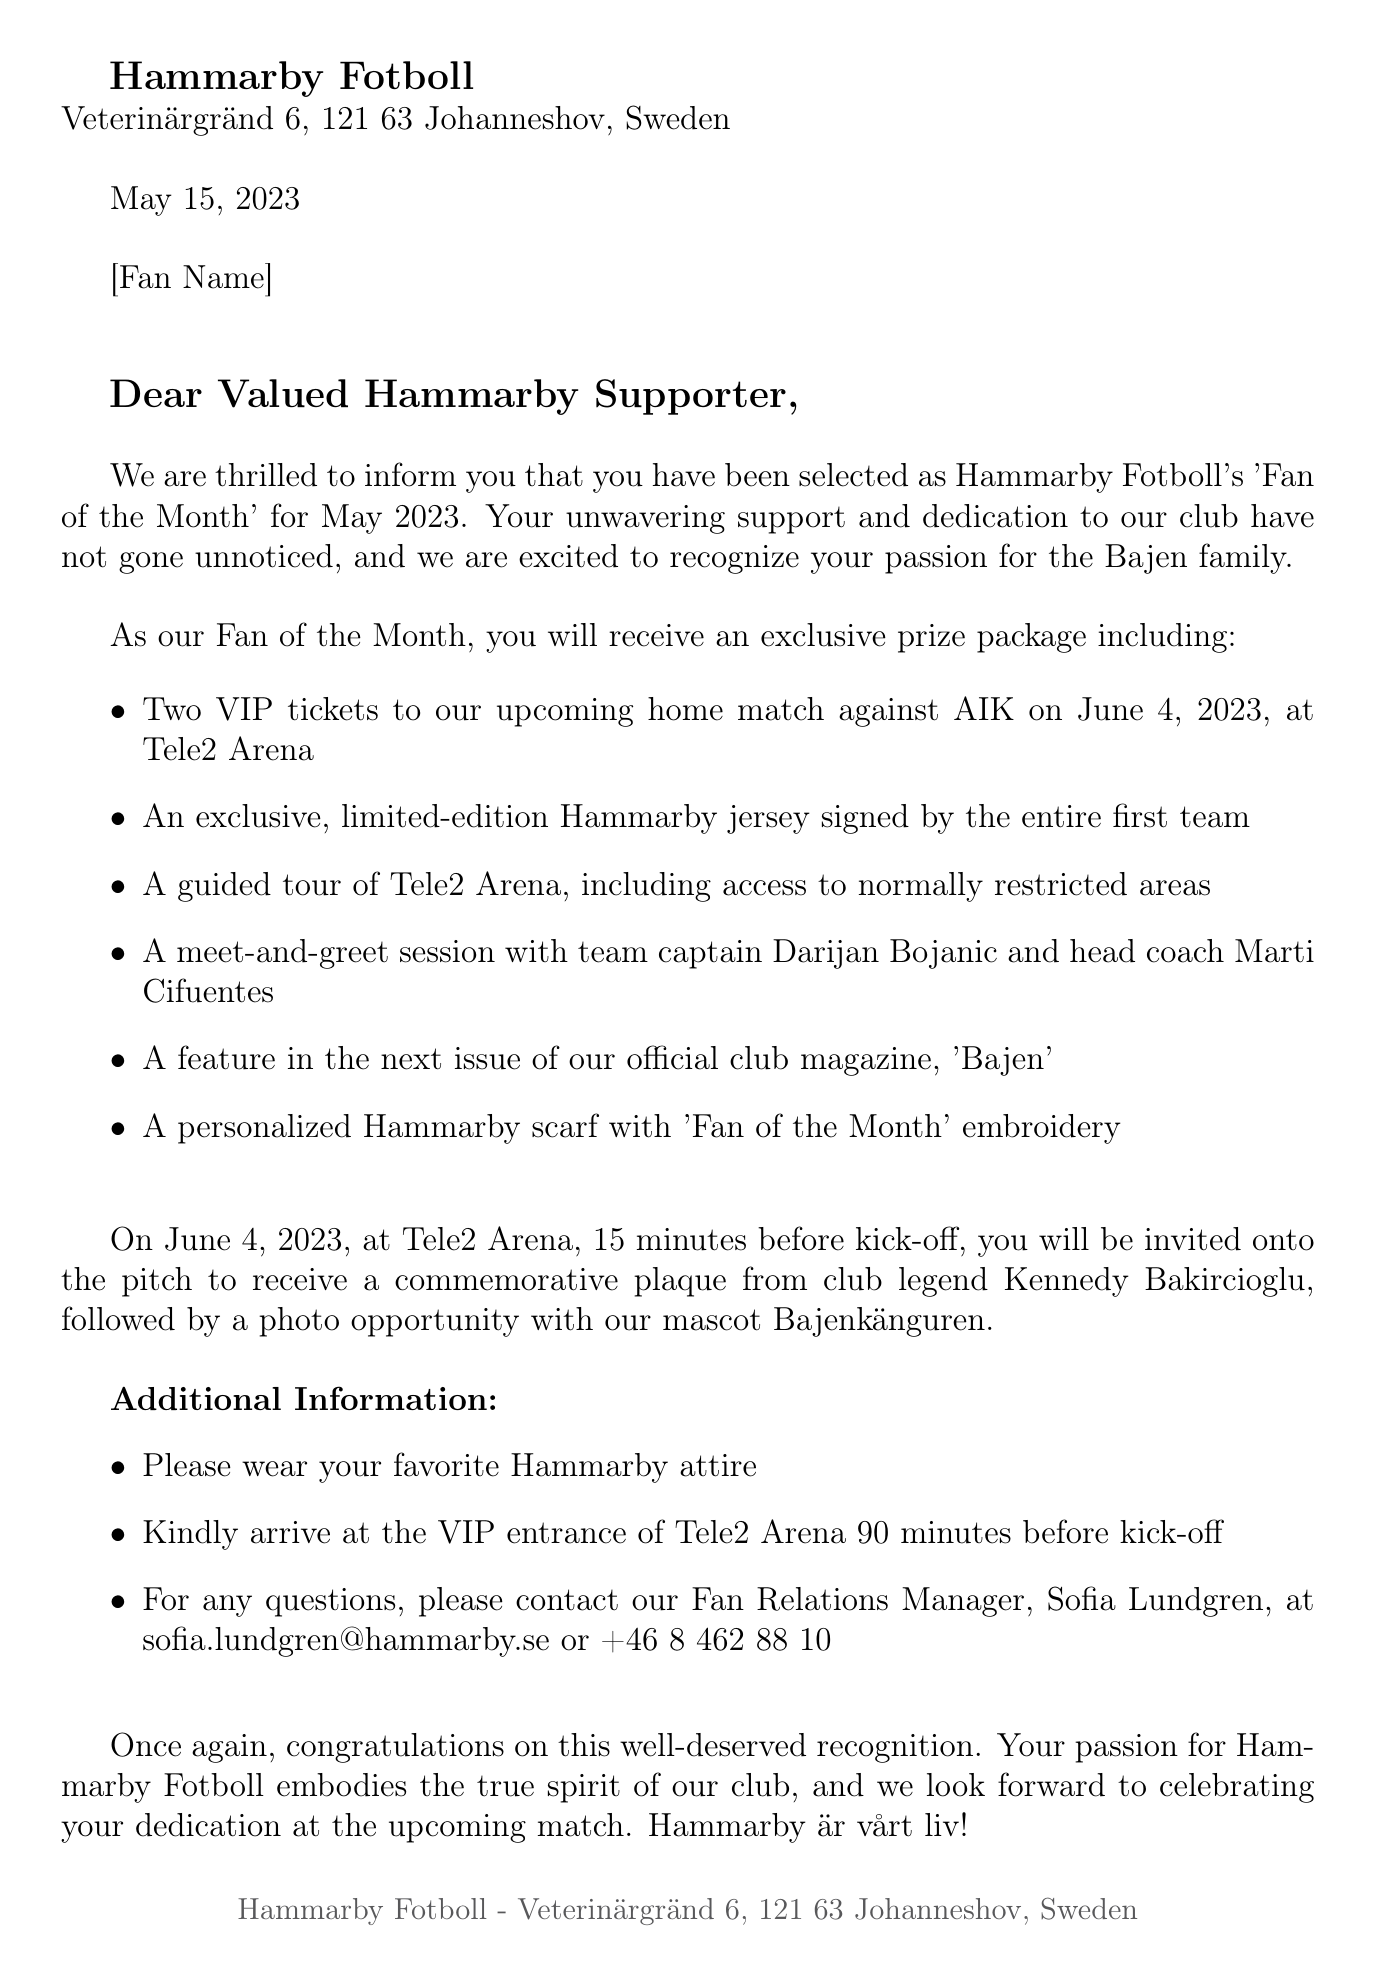what is the name of the recipient? The recipient's name is mentioned as [Fan Name] in the letter.
Answer: [Fan Name] what is the date of the upcoming home match? The letter states that the upcoming home match is on June 4, 2023.
Answer: June 4, 2023 who is the team captain mentioned in the letter? The letter specifies that the team captain is Darijan Bojanic.
Answer: Darijan Bojanic what prize includes a personalized item for the fan? The letter mentions a personalized Hammarby scarf with 'Fan of the Month' embroidery as part of the prize.
Answer: personalized Hammarby scarf when should the fan arrive at Tele2 Arena? The letter advises the fan to arrive at the VIP entrance 90 minutes before kick-off.
Answer: 90 minutes before kick-off how will the fan be recognized during the match? The letter states that the fan will receive a commemorative plaque from club legend Kennedy Bakircioglu on the pitch.
Answer: a commemorative plaque what type of document is this? This document is an official notification letter.
Answer: notification letter what is the dress code for the event? The letter specifies that the dress code is to wear the fan's favorite Hammarby attire.
Answer: favorite Hammarby attire what is included in the prize package? The letter lists multiple items in the prize package, including VIP tickets and a signed jersey.
Answer: VIP tickets and signed jersey 